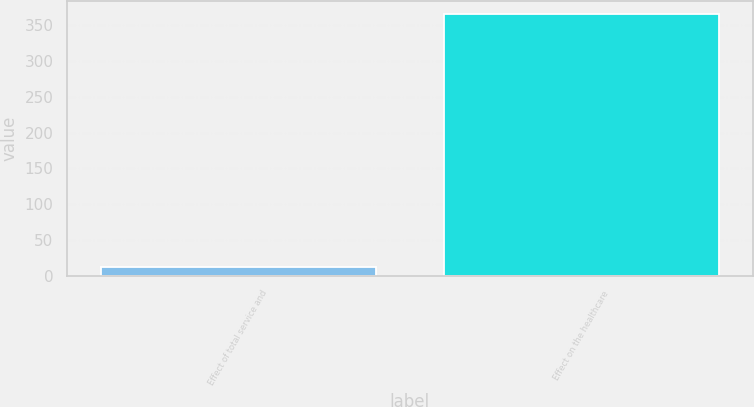Convert chart. <chart><loc_0><loc_0><loc_500><loc_500><bar_chart><fcel>Effect of total service and<fcel>Effect on the healthcare<nl><fcel>12<fcel>366<nl></chart> 